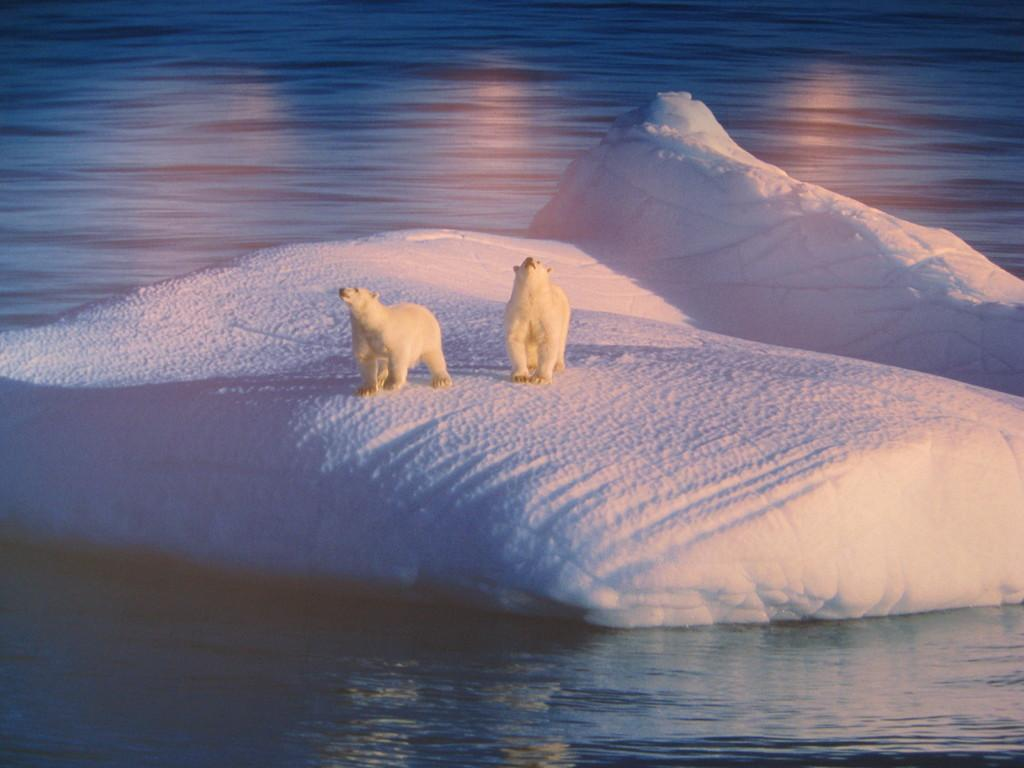What animals are present in the image? There are two polar bears in the image. Where are the polar bears located? The polar bears are on an iceberg. What can be seen around the iceberg? There is water flow visible around the iceberg. Where is the seat located in the image? There is no seat present in the image. Can you see a ship in the image? No, there is no ship visible in the image. 